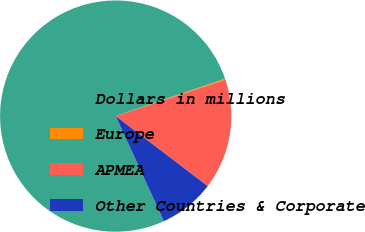<chart> <loc_0><loc_0><loc_500><loc_500><pie_chart><fcel>Dollars in millions<fcel>Europe<fcel>APMEA<fcel>Other Countries & Corporate<nl><fcel>76.61%<fcel>0.15%<fcel>15.44%<fcel>7.8%<nl></chart> 